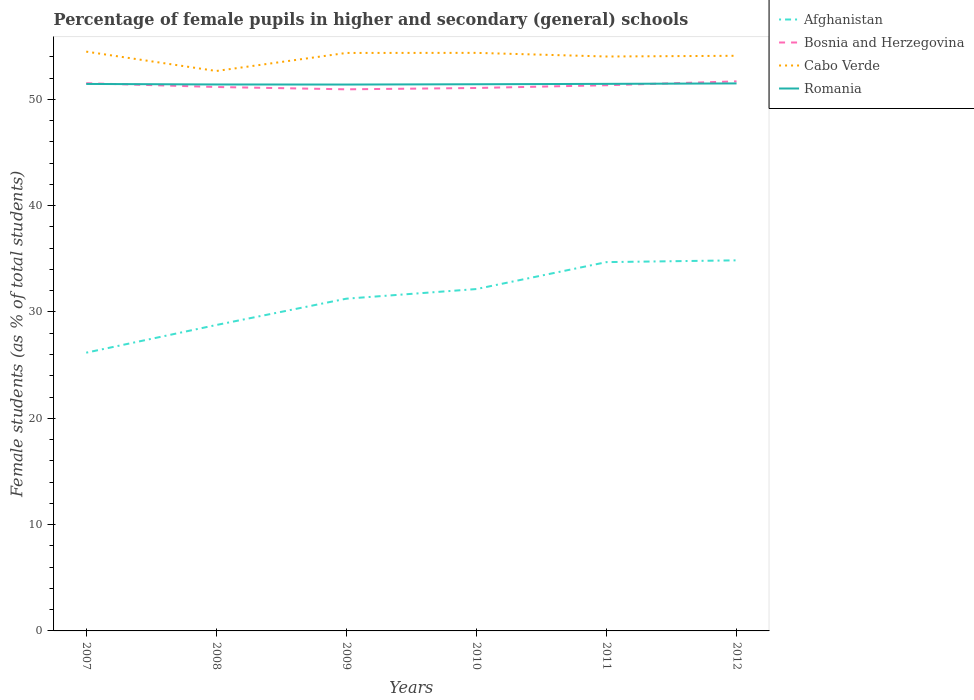Does the line corresponding to Afghanistan intersect with the line corresponding to Cabo Verde?
Provide a short and direct response. No. Is the number of lines equal to the number of legend labels?
Give a very brief answer. Yes. Across all years, what is the maximum percentage of female pupils in higher and secondary schools in Cabo Verde?
Give a very brief answer. 52.66. What is the total percentage of female pupils in higher and secondary schools in Cabo Verde in the graph?
Ensure brevity in your answer.  1.82. What is the difference between the highest and the second highest percentage of female pupils in higher and secondary schools in Cabo Verde?
Your answer should be compact. 1.82. Is the percentage of female pupils in higher and secondary schools in Cabo Verde strictly greater than the percentage of female pupils in higher and secondary schools in Romania over the years?
Provide a short and direct response. No. How many lines are there?
Provide a succinct answer. 4. Are the values on the major ticks of Y-axis written in scientific E-notation?
Make the answer very short. No. Does the graph contain grids?
Your response must be concise. No. Where does the legend appear in the graph?
Offer a very short reply. Top right. How many legend labels are there?
Provide a succinct answer. 4. What is the title of the graph?
Provide a short and direct response. Percentage of female pupils in higher and secondary (general) schools. What is the label or title of the Y-axis?
Give a very brief answer. Female students (as % of total students). What is the Female students (as % of total students) of Afghanistan in 2007?
Offer a terse response. 26.17. What is the Female students (as % of total students) in Bosnia and Herzegovina in 2007?
Ensure brevity in your answer.  51.51. What is the Female students (as % of total students) in Cabo Verde in 2007?
Offer a very short reply. 54.48. What is the Female students (as % of total students) of Romania in 2007?
Give a very brief answer. 51.45. What is the Female students (as % of total students) of Afghanistan in 2008?
Your answer should be compact. 28.77. What is the Female students (as % of total students) of Bosnia and Herzegovina in 2008?
Ensure brevity in your answer.  51.16. What is the Female students (as % of total students) in Cabo Verde in 2008?
Give a very brief answer. 52.66. What is the Female students (as % of total students) in Romania in 2008?
Offer a very short reply. 51.4. What is the Female students (as % of total students) in Afghanistan in 2009?
Your answer should be very brief. 31.25. What is the Female students (as % of total students) in Bosnia and Herzegovina in 2009?
Provide a succinct answer. 50.94. What is the Female students (as % of total students) of Cabo Verde in 2009?
Give a very brief answer. 54.36. What is the Female students (as % of total students) of Romania in 2009?
Make the answer very short. 51.39. What is the Female students (as % of total students) in Afghanistan in 2010?
Provide a succinct answer. 32.15. What is the Female students (as % of total students) of Bosnia and Herzegovina in 2010?
Offer a very short reply. 51.06. What is the Female students (as % of total students) in Cabo Verde in 2010?
Offer a very short reply. 54.37. What is the Female students (as % of total students) in Romania in 2010?
Your answer should be very brief. 51.42. What is the Female students (as % of total students) of Afghanistan in 2011?
Offer a very short reply. 34.69. What is the Female students (as % of total students) of Bosnia and Herzegovina in 2011?
Offer a very short reply. 51.32. What is the Female students (as % of total students) in Cabo Verde in 2011?
Offer a very short reply. 54.03. What is the Female students (as % of total students) of Romania in 2011?
Keep it short and to the point. 51.45. What is the Female students (as % of total students) of Afghanistan in 2012?
Provide a short and direct response. 34.85. What is the Female students (as % of total students) in Bosnia and Herzegovina in 2012?
Offer a terse response. 51.69. What is the Female students (as % of total students) in Cabo Verde in 2012?
Make the answer very short. 54.09. What is the Female students (as % of total students) in Romania in 2012?
Your answer should be compact. 51.49. Across all years, what is the maximum Female students (as % of total students) in Afghanistan?
Provide a succinct answer. 34.85. Across all years, what is the maximum Female students (as % of total students) in Bosnia and Herzegovina?
Give a very brief answer. 51.69. Across all years, what is the maximum Female students (as % of total students) of Cabo Verde?
Offer a very short reply. 54.48. Across all years, what is the maximum Female students (as % of total students) of Romania?
Your answer should be very brief. 51.49. Across all years, what is the minimum Female students (as % of total students) of Afghanistan?
Your answer should be very brief. 26.17. Across all years, what is the minimum Female students (as % of total students) of Bosnia and Herzegovina?
Keep it short and to the point. 50.94. Across all years, what is the minimum Female students (as % of total students) of Cabo Verde?
Your answer should be compact. 52.66. Across all years, what is the minimum Female students (as % of total students) in Romania?
Provide a succinct answer. 51.39. What is the total Female students (as % of total students) in Afghanistan in the graph?
Ensure brevity in your answer.  187.88. What is the total Female students (as % of total students) in Bosnia and Herzegovina in the graph?
Provide a succinct answer. 307.69. What is the total Female students (as % of total students) in Cabo Verde in the graph?
Keep it short and to the point. 324. What is the total Female students (as % of total students) of Romania in the graph?
Offer a terse response. 308.59. What is the difference between the Female students (as % of total students) in Afghanistan in 2007 and that in 2008?
Your answer should be very brief. -2.6. What is the difference between the Female students (as % of total students) in Bosnia and Herzegovina in 2007 and that in 2008?
Keep it short and to the point. 0.36. What is the difference between the Female students (as % of total students) in Cabo Verde in 2007 and that in 2008?
Give a very brief answer. 1.82. What is the difference between the Female students (as % of total students) in Romania in 2007 and that in 2008?
Give a very brief answer. 0.05. What is the difference between the Female students (as % of total students) in Afghanistan in 2007 and that in 2009?
Provide a succinct answer. -5.08. What is the difference between the Female students (as % of total students) of Bosnia and Herzegovina in 2007 and that in 2009?
Offer a terse response. 0.57. What is the difference between the Female students (as % of total students) in Cabo Verde in 2007 and that in 2009?
Your response must be concise. 0.12. What is the difference between the Female students (as % of total students) in Romania in 2007 and that in 2009?
Make the answer very short. 0.06. What is the difference between the Female students (as % of total students) in Afghanistan in 2007 and that in 2010?
Your response must be concise. -5.99. What is the difference between the Female students (as % of total students) in Bosnia and Herzegovina in 2007 and that in 2010?
Make the answer very short. 0.45. What is the difference between the Female students (as % of total students) of Cabo Verde in 2007 and that in 2010?
Make the answer very short. 0.12. What is the difference between the Female students (as % of total students) of Romania in 2007 and that in 2010?
Your answer should be very brief. 0.03. What is the difference between the Female students (as % of total students) in Afghanistan in 2007 and that in 2011?
Offer a terse response. -8.52. What is the difference between the Female students (as % of total students) of Bosnia and Herzegovina in 2007 and that in 2011?
Provide a short and direct response. 0.19. What is the difference between the Female students (as % of total students) in Cabo Verde in 2007 and that in 2011?
Offer a terse response. 0.46. What is the difference between the Female students (as % of total students) in Romania in 2007 and that in 2011?
Ensure brevity in your answer.  -0.01. What is the difference between the Female students (as % of total students) of Afghanistan in 2007 and that in 2012?
Ensure brevity in your answer.  -8.68. What is the difference between the Female students (as % of total students) of Bosnia and Herzegovina in 2007 and that in 2012?
Your response must be concise. -0.17. What is the difference between the Female students (as % of total students) of Cabo Verde in 2007 and that in 2012?
Keep it short and to the point. 0.39. What is the difference between the Female students (as % of total students) of Romania in 2007 and that in 2012?
Make the answer very short. -0.05. What is the difference between the Female students (as % of total students) of Afghanistan in 2008 and that in 2009?
Offer a very short reply. -2.48. What is the difference between the Female students (as % of total students) in Bosnia and Herzegovina in 2008 and that in 2009?
Make the answer very short. 0.22. What is the difference between the Female students (as % of total students) in Cabo Verde in 2008 and that in 2009?
Provide a succinct answer. -1.7. What is the difference between the Female students (as % of total students) of Romania in 2008 and that in 2009?
Your answer should be very brief. 0.01. What is the difference between the Female students (as % of total students) of Afghanistan in 2008 and that in 2010?
Your answer should be very brief. -3.38. What is the difference between the Female students (as % of total students) of Bosnia and Herzegovina in 2008 and that in 2010?
Offer a terse response. 0.09. What is the difference between the Female students (as % of total students) of Cabo Verde in 2008 and that in 2010?
Provide a succinct answer. -1.7. What is the difference between the Female students (as % of total students) of Romania in 2008 and that in 2010?
Offer a terse response. -0.02. What is the difference between the Female students (as % of total students) of Afghanistan in 2008 and that in 2011?
Make the answer very short. -5.92. What is the difference between the Female students (as % of total students) in Bosnia and Herzegovina in 2008 and that in 2011?
Ensure brevity in your answer.  -0.17. What is the difference between the Female students (as % of total students) of Cabo Verde in 2008 and that in 2011?
Your response must be concise. -1.36. What is the difference between the Female students (as % of total students) of Romania in 2008 and that in 2011?
Offer a terse response. -0.06. What is the difference between the Female students (as % of total students) in Afghanistan in 2008 and that in 2012?
Make the answer very short. -6.08. What is the difference between the Female students (as % of total students) in Bosnia and Herzegovina in 2008 and that in 2012?
Your answer should be compact. -0.53. What is the difference between the Female students (as % of total students) of Cabo Verde in 2008 and that in 2012?
Give a very brief answer. -1.43. What is the difference between the Female students (as % of total students) of Romania in 2008 and that in 2012?
Make the answer very short. -0.1. What is the difference between the Female students (as % of total students) of Afghanistan in 2009 and that in 2010?
Offer a terse response. -0.91. What is the difference between the Female students (as % of total students) in Bosnia and Herzegovina in 2009 and that in 2010?
Provide a succinct answer. -0.12. What is the difference between the Female students (as % of total students) of Cabo Verde in 2009 and that in 2010?
Your answer should be very brief. -0.01. What is the difference between the Female students (as % of total students) in Romania in 2009 and that in 2010?
Provide a succinct answer. -0.03. What is the difference between the Female students (as % of total students) of Afghanistan in 2009 and that in 2011?
Your answer should be compact. -3.44. What is the difference between the Female students (as % of total students) of Bosnia and Herzegovina in 2009 and that in 2011?
Offer a terse response. -0.38. What is the difference between the Female students (as % of total students) in Cabo Verde in 2009 and that in 2011?
Give a very brief answer. 0.34. What is the difference between the Female students (as % of total students) in Romania in 2009 and that in 2011?
Offer a very short reply. -0.06. What is the difference between the Female students (as % of total students) of Afghanistan in 2009 and that in 2012?
Your answer should be compact. -3.61. What is the difference between the Female students (as % of total students) in Bosnia and Herzegovina in 2009 and that in 2012?
Your answer should be very brief. -0.75. What is the difference between the Female students (as % of total students) in Cabo Verde in 2009 and that in 2012?
Keep it short and to the point. 0.27. What is the difference between the Female students (as % of total students) of Romania in 2009 and that in 2012?
Ensure brevity in your answer.  -0.11. What is the difference between the Female students (as % of total students) in Afghanistan in 2010 and that in 2011?
Offer a very short reply. -2.53. What is the difference between the Female students (as % of total students) of Bosnia and Herzegovina in 2010 and that in 2011?
Keep it short and to the point. -0.26. What is the difference between the Female students (as % of total students) of Cabo Verde in 2010 and that in 2011?
Offer a very short reply. 0.34. What is the difference between the Female students (as % of total students) in Romania in 2010 and that in 2011?
Ensure brevity in your answer.  -0.04. What is the difference between the Female students (as % of total students) in Afghanistan in 2010 and that in 2012?
Offer a terse response. -2.7. What is the difference between the Female students (as % of total students) in Bosnia and Herzegovina in 2010 and that in 2012?
Provide a succinct answer. -0.62. What is the difference between the Female students (as % of total students) in Cabo Verde in 2010 and that in 2012?
Provide a short and direct response. 0.27. What is the difference between the Female students (as % of total students) in Romania in 2010 and that in 2012?
Ensure brevity in your answer.  -0.08. What is the difference between the Female students (as % of total students) in Afghanistan in 2011 and that in 2012?
Offer a terse response. -0.17. What is the difference between the Female students (as % of total students) in Bosnia and Herzegovina in 2011 and that in 2012?
Provide a succinct answer. -0.36. What is the difference between the Female students (as % of total students) of Cabo Verde in 2011 and that in 2012?
Keep it short and to the point. -0.07. What is the difference between the Female students (as % of total students) of Romania in 2011 and that in 2012?
Provide a short and direct response. -0.04. What is the difference between the Female students (as % of total students) of Afghanistan in 2007 and the Female students (as % of total students) of Bosnia and Herzegovina in 2008?
Provide a succinct answer. -24.99. What is the difference between the Female students (as % of total students) in Afghanistan in 2007 and the Female students (as % of total students) in Cabo Verde in 2008?
Your answer should be compact. -26.49. What is the difference between the Female students (as % of total students) of Afghanistan in 2007 and the Female students (as % of total students) of Romania in 2008?
Keep it short and to the point. -25.23. What is the difference between the Female students (as % of total students) in Bosnia and Herzegovina in 2007 and the Female students (as % of total students) in Cabo Verde in 2008?
Your answer should be compact. -1.15. What is the difference between the Female students (as % of total students) of Bosnia and Herzegovina in 2007 and the Female students (as % of total students) of Romania in 2008?
Your answer should be compact. 0.12. What is the difference between the Female students (as % of total students) in Cabo Verde in 2007 and the Female students (as % of total students) in Romania in 2008?
Make the answer very short. 3.09. What is the difference between the Female students (as % of total students) in Afghanistan in 2007 and the Female students (as % of total students) in Bosnia and Herzegovina in 2009?
Your response must be concise. -24.77. What is the difference between the Female students (as % of total students) in Afghanistan in 2007 and the Female students (as % of total students) in Cabo Verde in 2009?
Make the answer very short. -28.19. What is the difference between the Female students (as % of total students) in Afghanistan in 2007 and the Female students (as % of total students) in Romania in 2009?
Provide a succinct answer. -25.22. What is the difference between the Female students (as % of total students) in Bosnia and Herzegovina in 2007 and the Female students (as % of total students) in Cabo Verde in 2009?
Your answer should be compact. -2.85. What is the difference between the Female students (as % of total students) of Bosnia and Herzegovina in 2007 and the Female students (as % of total students) of Romania in 2009?
Provide a succinct answer. 0.12. What is the difference between the Female students (as % of total students) of Cabo Verde in 2007 and the Female students (as % of total students) of Romania in 2009?
Your answer should be compact. 3.1. What is the difference between the Female students (as % of total students) of Afghanistan in 2007 and the Female students (as % of total students) of Bosnia and Herzegovina in 2010?
Provide a succinct answer. -24.9. What is the difference between the Female students (as % of total students) in Afghanistan in 2007 and the Female students (as % of total students) in Cabo Verde in 2010?
Offer a very short reply. -28.2. What is the difference between the Female students (as % of total students) in Afghanistan in 2007 and the Female students (as % of total students) in Romania in 2010?
Your response must be concise. -25.25. What is the difference between the Female students (as % of total students) of Bosnia and Herzegovina in 2007 and the Female students (as % of total students) of Cabo Verde in 2010?
Give a very brief answer. -2.85. What is the difference between the Female students (as % of total students) in Bosnia and Herzegovina in 2007 and the Female students (as % of total students) in Romania in 2010?
Offer a very short reply. 0.1. What is the difference between the Female students (as % of total students) in Cabo Verde in 2007 and the Female students (as % of total students) in Romania in 2010?
Make the answer very short. 3.07. What is the difference between the Female students (as % of total students) of Afghanistan in 2007 and the Female students (as % of total students) of Bosnia and Herzegovina in 2011?
Provide a succinct answer. -25.15. What is the difference between the Female students (as % of total students) in Afghanistan in 2007 and the Female students (as % of total students) in Cabo Verde in 2011?
Your answer should be compact. -27.86. What is the difference between the Female students (as % of total students) in Afghanistan in 2007 and the Female students (as % of total students) in Romania in 2011?
Offer a terse response. -25.28. What is the difference between the Female students (as % of total students) in Bosnia and Herzegovina in 2007 and the Female students (as % of total students) in Cabo Verde in 2011?
Offer a very short reply. -2.51. What is the difference between the Female students (as % of total students) of Cabo Verde in 2007 and the Female students (as % of total students) of Romania in 2011?
Your answer should be compact. 3.03. What is the difference between the Female students (as % of total students) of Afghanistan in 2007 and the Female students (as % of total students) of Bosnia and Herzegovina in 2012?
Provide a succinct answer. -25.52. What is the difference between the Female students (as % of total students) of Afghanistan in 2007 and the Female students (as % of total students) of Cabo Verde in 2012?
Ensure brevity in your answer.  -27.92. What is the difference between the Female students (as % of total students) in Afghanistan in 2007 and the Female students (as % of total students) in Romania in 2012?
Give a very brief answer. -25.32. What is the difference between the Female students (as % of total students) of Bosnia and Herzegovina in 2007 and the Female students (as % of total students) of Cabo Verde in 2012?
Your answer should be very brief. -2.58. What is the difference between the Female students (as % of total students) in Bosnia and Herzegovina in 2007 and the Female students (as % of total students) in Romania in 2012?
Provide a succinct answer. 0.02. What is the difference between the Female students (as % of total students) of Cabo Verde in 2007 and the Female students (as % of total students) of Romania in 2012?
Give a very brief answer. 2.99. What is the difference between the Female students (as % of total students) of Afghanistan in 2008 and the Female students (as % of total students) of Bosnia and Herzegovina in 2009?
Offer a terse response. -22.17. What is the difference between the Female students (as % of total students) of Afghanistan in 2008 and the Female students (as % of total students) of Cabo Verde in 2009?
Provide a succinct answer. -25.59. What is the difference between the Female students (as % of total students) in Afghanistan in 2008 and the Female students (as % of total students) in Romania in 2009?
Make the answer very short. -22.62. What is the difference between the Female students (as % of total students) of Bosnia and Herzegovina in 2008 and the Female students (as % of total students) of Cabo Verde in 2009?
Provide a short and direct response. -3.2. What is the difference between the Female students (as % of total students) of Bosnia and Herzegovina in 2008 and the Female students (as % of total students) of Romania in 2009?
Ensure brevity in your answer.  -0.23. What is the difference between the Female students (as % of total students) of Cabo Verde in 2008 and the Female students (as % of total students) of Romania in 2009?
Your response must be concise. 1.28. What is the difference between the Female students (as % of total students) in Afghanistan in 2008 and the Female students (as % of total students) in Bosnia and Herzegovina in 2010?
Offer a terse response. -22.29. What is the difference between the Female students (as % of total students) in Afghanistan in 2008 and the Female students (as % of total students) in Cabo Verde in 2010?
Make the answer very short. -25.6. What is the difference between the Female students (as % of total students) of Afghanistan in 2008 and the Female students (as % of total students) of Romania in 2010?
Your answer should be compact. -22.64. What is the difference between the Female students (as % of total students) in Bosnia and Herzegovina in 2008 and the Female students (as % of total students) in Cabo Verde in 2010?
Your response must be concise. -3.21. What is the difference between the Female students (as % of total students) in Bosnia and Herzegovina in 2008 and the Female students (as % of total students) in Romania in 2010?
Provide a succinct answer. -0.26. What is the difference between the Female students (as % of total students) in Cabo Verde in 2008 and the Female students (as % of total students) in Romania in 2010?
Your answer should be compact. 1.25. What is the difference between the Female students (as % of total students) of Afghanistan in 2008 and the Female students (as % of total students) of Bosnia and Herzegovina in 2011?
Give a very brief answer. -22.55. What is the difference between the Female students (as % of total students) in Afghanistan in 2008 and the Female students (as % of total students) in Cabo Verde in 2011?
Your response must be concise. -25.25. What is the difference between the Female students (as % of total students) in Afghanistan in 2008 and the Female students (as % of total students) in Romania in 2011?
Provide a succinct answer. -22.68. What is the difference between the Female students (as % of total students) in Bosnia and Herzegovina in 2008 and the Female students (as % of total students) in Cabo Verde in 2011?
Offer a very short reply. -2.87. What is the difference between the Female students (as % of total students) of Bosnia and Herzegovina in 2008 and the Female students (as % of total students) of Romania in 2011?
Give a very brief answer. -0.3. What is the difference between the Female students (as % of total students) of Cabo Verde in 2008 and the Female students (as % of total students) of Romania in 2011?
Provide a succinct answer. 1.21. What is the difference between the Female students (as % of total students) of Afghanistan in 2008 and the Female students (as % of total students) of Bosnia and Herzegovina in 2012?
Provide a short and direct response. -22.92. What is the difference between the Female students (as % of total students) of Afghanistan in 2008 and the Female students (as % of total students) of Cabo Verde in 2012?
Make the answer very short. -25.32. What is the difference between the Female students (as % of total students) in Afghanistan in 2008 and the Female students (as % of total students) in Romania in 2012?
Ensure brevity in your answer.  -22.72. What is the difference between the Female students (as % of total students) in Bosnia and Herzegovina in 2008 and the Female students (as % of total students) in Cabo Verde in 2012?
Offer a very short reply. -2.94. What is the difference between the Female students (as % of total students) of Bosnia and Herzegovina in 2008 and the Female students (as % of total students) of Romania in 2012?
Offer a terse response. -0.34. What is the difference between the Female students (as % of total students) of Cabo Verde in 2008 and the Female students (as % of total students) of Romania in 2012?
Provide a short and direct response. 1.17. What is the difference between the Female students (as % of total students) of Afghanistan in 2009 and the Female students (as % of total students) of Bosnia and Herzegovina in 2010?
Provide a short and direct response. -19.82. What is the difference between the Female students (as % of total students) in Afghanistan in 2009 and the Female students (as % of total students) in Cabo Verde in 2010?
Offer a terse response. -23.12. What is the difference between the Female students (as % of total students) in Afghanistan in 2009 and the Female students (as % of total students) in Romania in 2010?
Your response must be concise. -20.17. What is the difference between the Female students (as % of total students) of Bosnia and Herzegovina in 2009 and the Female students (as % of total students) of Cabo Verde in 2010?
Your answer should be very brief. -3.43. What is the difference between the Female students (as % of total students) of Bosnia and Herzegovina in 2009 and the Female students (as % of total students) of Romania in 2010?
Offer a very short reply. -0.48. What is the difference between the Female students (as % of total students) of Cabo Verde in 2009 and the Female students (as % of total students) of Romania in 2010?
Offer a very short reply. 2.94. What is the difference between the Female students (as % of total students) of Afghanistan in 2009 and the Female students (as % of total students) of Bosnia and Herzegovina in 2011?
Your response must be concise. -20.08. What is the difference between the Female students (as % of total students) of Afghanistan in 2009 and the Female students (as % of total students) of Cabo Verde in 2011?
Your answer should be very brief. -22.78. What is the difference between the Female students (as % of total students) in Afghanistan in 2009 and the Female students (as % of total students) in Romania in 2011?
Keep it short and to the point. -20.2. What is the difference between the Female students (as % of total students) of Bosnia and Herzegovina in 2009 and the Female students (as % of total students) of Cabo Verde in 2011?
Offer a terse response. -3.09. What is the difference between the Female students (as % of total students) in Bosnia and Herzegovina in 2009 and the Female students (as % of total students) in Romania in 2011?
Keep it short and to the point. -0.51. What is the difference between the Female students (as % of total students) of Cabo Verde in 2009 and the Female students (as % of total students) of Romania in 2011?
Offer a very short reply. 2.91. What is the difference between the Female students (as % of total students) in Afghanistan in 2009 and the Female students (as % of total students) in Bosnia and Herzegovina in 2012?
Offer a terse response. -20.44. What is the difference between the Female students (as % of total students) in Afghanistan in 2009 and the Female students (as % of total students) in Cabo Verde in 2012?
Offer a terse response. -22.84. What is the difference between the Female students (as % of total students) of Afghanistan in 2009 and the Female students (as % of total students) of Romania in 2012?
Give a very brief answer. -20.25. What is the difference between the Female students (as % of total students) in Bosnia and Herzegovina in 2009 and the Female students (as % of total students) in Cabo Verde in 2012?
Offer a very short reply. -3.15. What is the difference between the Female students (as % of total students) in Bosnia and Herzegovina in 2009 and the Female students (as % of total students) in Romania in 2012?
Ensure brevity in your answer.  -0.55. What is the difference between the Female students (as % of total students) in Cabo Verde in 2009 and the Female students (as % of total students) in Romania in 2012?
Offer a very short reply. 2.87. What is the difference between the Female students (as % of total students) in Afghanistan in 2010 and the Female students (as % of total students) in Bosnia and Herzegovina in 2011?
Provide a succinct answer. -19.17. What is the difference between the Female students (as % of total students) in Afghanistan in 2010 and the Female students (as % of total students) in Cabo Verde in 2011?
Provide a short and direct response. -21.87. What is the difference between the Female students (as % of total students) of Afghanistan in 2010 and the Female students (as % of total students) of Romania in 2011?
Your answer should be very brief. -19.3. What is the difference between the Female students (as % of total students) in Bosnia and Herzegovina in 2010 and the Female students (as % of total students) in Cabo Verde in 2011?
Give a very brief answer. -2.96. What is the difference between the Female students (as % of total students) in Bosnia and Herzegovina in 2010 and the Female students (as % of total students) in Romania in 2011?
Ensure brevity in your answer.  -0.39. What is the difference between the Female students (as % of total students) in Cabo Verde in 2010 and the Female students (as % of total students) in Romania in 2011?
Ensure brevity in your answer.  2.91. What is the difference between the Female students (as % of total students) in Afghanistan in 2010 and the Female students (as % of total students) in Bosnia and Herzegovina in 2012?
Give a very brief answer. -19.53. What is the difference between the Female students (as % of total students) of Afghanistan in 2010 and the Female students (as % of total students) of Cabo Verde in 2012?
Your response must be concise. -21.94. What is the difference between the Female students (as % of total students) in Afghanistan in 2010 and the Female students (as % of total students) in Romania in 2012?
Give a very brief answer. -19.34. What is the difference between the Female students (as % of total students) of Bosnia and Herzegovina in 2010 and the Female students (as % of total students) of Cabo Verde in 2012?
Ensure brevity in your answer.  -3.03. What is the difference between the Female students (as % of total students) of Bosnia and Herzegovina in 2010 and the Female students (as % of total students) of Romania in 2012?
Offer a very short reply. -0.43. What is the difference between the Female students (as % of total students) in Cabo Verde in 2010 and the Female students (as % of total students) in Romania in 2012?
Provide a succinct answer. 2.87. What is the difference between the Female students (as % of total students) in Afghanistan in 2011 and the Female students (as % of total students) in Bosnia and Herzegovina in 2012?
Provide a succinct answer. -17. What is the difference between the Female students (as % of total students) of Afghanistan in 2011 and the Female students (as % of total students) of Cabo Verde in 2012?
Provide a succinct answer. -19.41. What is the difference between the Female students (as % of total students) of Afghanistan in 2011 and the Female students (as % of total students) of Romania in 2012?
Provide a succinct answer. -16.81. What is the difference between the Female students (as % of total students) in Bosnia and Herzegovina in 2011 and the Female students (as % of total students) in Cabo Verde in 2012?
Your response must be concise. -2.77. What is the difference between the Female students (as % of total students) in Bosnia and Herzegovina in 2011 and the Female students (as % of total students) in Romania in 2012?
Keep it short and to the point. -0.17. What is the difference between the Female students (as % of total students) of Cabo Verde in 2011 and the Female students (as % of total students) of Romania in 2012?
Your answer should be very brief. 2.53. What is the average Female students (as % of total students) in Afghanistan per year?
Your response must be concise. 31.31. What is the average Female students (as % of total students) of Bosnia and Herzegovina per year?
Ensure brevity in your answer.  51.28. What is the average Female students (as % of total students) in Cabo Verde per year?
Give a very brief answer. 54. What is the average Female students (as % of total students) in Romania per year?
Make the answer very short. 51.43. In the year 2007, what is the difference between the Female students (as % of total students) of Afghanistan and Female students (as % of total students) of Bosnia and Herzegovina?
Offer a very short reply. -25.34. In the year 2007, what is the difference between the Female students (as % of total students) of Afghanistan and Female students (as % of total students) of Cabo Verde?
Offer a terse response. -28.32. In the year 2007, what is the difference between the Female students (as % of total students) in Afghanistan and Female students (as % of total students) in Romania?
Make the answer very short. -25.28. In the year 2007, what is the difference between the Female students (as % of total students) in Bosnia and Herzegovina and Female students (as % of total students) in Cabo Verde?
Offer a very short reply. -2.97. In the year 2007, what is the difference between the Female students (as % of total students) in Bosnia and Herzegovina and Female students (as % of total students) in Romania?
Keep it short and to the point. 0.07. In the year 2007, what is the difference between the Female students (as % of total students) in Cabo Verde and Female students (as % of total students) in Romania?
Provide a succinct answer. 3.04. In the year 2008, what is the difference between the Female students (as % of total students) in Afghanistan and Female students (as % of total students) in Bosnia and Herzegovina?
Offer a very short reply. -22.39. In the year 2008, what is the difference between the Female students (as % of total students) in Afghanistan and Female students (as % of total students) in Cabo Verde?
Your response must be concise. -23.89. In the year 2008, what is the difference between the Female students (as % of total students) in Afghanistan and Female students (as % of total students) in Romania?
Provide a succinct answer. -22.62. In the year 2008, what is the difference between the Female students (as % of total students) in Bosnia and Herzegovina and Female students (as % of total students) in Cabo Verde?
Keep it short and to the point. -1.51. In the year 2008, what is the difference between the Female students (as % of total students) in Bosnia and Herzegovina and Female students (as % of total students) in Romania?
Your response must be concise. -0.24. In the year 2008, what is the difference between the Female students (as % of total students) in Cabo Verde and Female students (as % of total students) in Romania?
Your answer should be compact. 1.27. In the year 2009, what is the difference between the Female students (as % of total students) of Afghanistan and Female students (as % of total students) of Bosnia and Herzegovina?
Give a very brief answer. -19.69. In the year 2009, what is the difference between the Female students (as % of total students) in Afghanistan and Female students (as % of total students) in Cabo Verde?
Your answer should be very brief. -23.11. In the year 2009, what is the difference between the Female students (as % of total students) of Afghanistan and Female students (as % of total students) of Romania?
Keep it short and to the point. -20.14. In the year 2009, what is the difference between the Female students (as % of total students) in Bosnia and Herzegovina and Female students (as % of total students) in Cabo Verde?
Provide a succinct answer. -3.42. In the year 2009, what is the difference between the Female students (as % of total students) of Bosnia and Herzegovina and Female students (as % of total students) of Romania?
Offer a very short reply. -0.45. In the year 2009, what is the difference between the Female students (as % of total students) in Cabo Verde and Female students (as % of total students) in Romania?
Offer a very short reply. 2.97. In the year 2010, what is the difference between the Female students (as % of total students) of Afghanistan and Female students (as % of total students) of Bosnia and Herzegovina?
Offer a very short reply. -18.91. In the year 2010, what is the difference between the Female students (as % of total students) of Afghanistan and Female students (as % of total students) of Cabo Verde?
Your answer should be very brief. -22.21. In the year 2010, what is the difference between the Female students (as % of total students) in Afghanistan and Female students (as % of total students) in Romania?
Offer a terse response. -19.26. In the year 2010, what is the difference between the Female students (as % of total students) of Bosnia and Herzegovina and Female students (as % of total students) of Cabo Verde?
Offer a very short reply. -3.3. In the year 2010, what is the difference between the Female students (as % of total students) in Bosnia and Herzegovina and Female students (as % of total students) in Romania?
Offer a terse response. -0.35. In the year 2010, what is the difference between the Female students (as % of total students) of Cabo Verde and Female students (as % of total students) of Romania?
Provide a short and direct response. 2.95. In the year 2011, what is the difference between the Female students (as % of total students) of Afghanistan and Female students (as % of total students) of Bosnia and Herzegovina?
Your answer should be compact. -16.64. In the year 2011, what is the difference between the Female students (as % of total students) in Afghanistan and Female students (as % of total students) in Cabo Verde?
Ensure brevity in your answer.  -19.34. In the year 2011, what is the difference between the Female students (as % of total students) in Afghanistan and Female students (as % of total students) in Romania?
Keep it short and to the point. -16.77. In the year 2011, what is the difference between the Female students (as % of total students) in Bosnia and Herzegovina and Female students (as % of total students) in Cabo Verde?
Your answer should be compact. -2.7. In the year 2011, what is the difference between the Female students (as % of total students) of Bosnia and Herzegovina and Female students (as % of total students) of Romania?
Ensure brevity in your answer.  -0.13. In the year 2011, what is the difference between the Female students (as % of total students) of Cabo Verde and Female students (as % of total students) of Romania?
Your answer should be compact. 2.57. In the year 2012, what is the difference between the Female students (as % of total students) of Afghanistan and Female students (as % of total students) of Bosnia and Herzegovina?
Your answer should be very brief. -16.83. In the year 2012, what is the difference between the Female students (as % of total students) of Afghanistan and Female students (as % of total students) of Cabo Verde?
Your answer should be very brief. -19.24. In the year 2012, what is the difference between the Female students (as % of total students) in Afghanistan and Female students (as % of total students) in Romania?
Provide a short and direct response. -16.64. In the year 2012, what is the difference between the Female students (as % of total students) in Bosnia and Herzegovina and Female students (as % of total students) in Cabo Verde?
Provide a short and direct response. -2.41. In the year 2012, what is the difference between the Female students (as % of total students) in Bosnia and Herzegovina and Female students (as % of total students) in Romania?
Offer a very short reply. 0.19. In the year 2012, what is the difference between the Female students (as % of total students) in Cabo Verde and Female students (as % of total students) in Romania?
Offer a terse response. 2.6. What is the ratio of the Female students (as % of total students) of Afghanistan in 2007 to that in 2008?
Keep it short and to the point. 0.91. What is the ratio of the Female students (as % of total students) in Bosnia and Herzegovina in 2007 to that in 2008?
Your response must be concise. 1.01. What is the ratio of the Female students (as % of total students) of Cabo Verde in 2007 to that in 2008?
Offer a very short reply. 1.03. What is the ratio of the Female students (as % of total students) of Afghanistan in 2007 to that in 2009?
Your answer should be compact. 0.84. What is the ratio of the Female students (as % of total students) of Bosnia and Herzegovina in 2007 to that in 2009?
Your answer should be compact. 1.01. What is the ratio of the Female students (as % of total students) of Romania in 2007 to that in 2009?
Your answer should be very brief. 1. What is the ratio of the Female students (as % of total students) of Afghanistan in 2007 to that in 2010?
Keep it short and to the point. 0.81. What is the ratio of the Female students (as % of total students) in Bosnia and Herzegovina in 2007 to that in 2010?
Provide a short and direct response. 1.01. What is the ratio of the Female students (as % of total students) in Cabo Verde in 2007 to that in 2010?
Provide a succinct answer. 1. What is the ratio of the Female students (as % of total students) in Romania in 2007 to that in 2010?
Make the answer very short. 1. What is the ratio of the Female students (as % of total students) in Afghanistan in 2007 to that in 2011?
Keep it short and to the point. 0.75. What is the ratio of the Female students (as % of total students) of Cabo Verde in 2007 to that in 2011?
Your response must be concise. 1.01. What is the ratio of the Female students (as % of total students) of Romania in 2007 to that in 2011?
Keep it short and to the point. 1. What is the ratio of the Female students (as % of total students) of Afghanistan in 2007 to that in 2012?
Provide a short and direct response. 0.75. What is the ratio of the Female students (as % of total students) in Cabo Verde in 2007 to that in 2012?
Offer a very short reply. 1.01. What is the ratio of the Female students (as % of total students) of Afghanistan in 2008 to that in 2009?
Ensure brevity in your answer.  0.92. What is the ratio of the Female students (as % of total students) in Bosnia and Herzegovina in 2008 to that in 2009?
Your answer should be very brief. 1. What is the ratio of the Female students (as % of total students) of Cabo Verde in 2008 to that in 2009?
Provide a succinct answer. 0.97. What is the ratio of the Female students (as % of total students) in Romania in 2008 to that in 2009?
Your answer should be very brief. 1. What is the ratio of the Female students (as % of total students) of Afghanistan in 2008 to that in 2010?
Give a very brief answer. 0.89. What is the ratio of the Female students (as % of total students) of Cabo Verde in 2008 to that in 2010?
Keep it short and to the point. 0.97. What is the ratio of the Female students (as % of total students) in Romania in 2008 to that in 2010?
Your answer should be very brief. 1. What is the ratio of the Female students (as % of total students) of Afghanistan in 2008 to that in 2011?
Ensure brevity in your answer.  0.83. What is the ratio of the Female students (as % of total students) of Cabo Verde in 2008 to that in 2011?
Your answer should be compact. 0.97. What is the ratio of the Female students (as % of total students) in Romania in 2008 to that in 2011?
Offer a very short reply. 1. What is the ratio of the Female students (as % of total students) of Afghanistan in 2008 to that in 2012?
Ensure brevity in your answer.  0.83. What is the ratio of the Female students (as % of total students) of Bosnia and Herzegovina in 2008 to that in 2012?
Give a very brief answer. 0.99. What is the ratio of the Female students (as % of total students) in Cabo Verde in 2008 to that in 2012?
Ensure brevity in your answer.  0.97. What is the ratio of the Female students (as % of total students) in Romania in 2008 to that in 2012?
Your response must be concise. 1. What is the ratio of the Female students (as % of total students) of Afghanistan in 2009 to that in 2010?
Offer a very short reply. 0.97. What is the ratio of the Female students (as % of total students) of Cabo Verde in 2009 to that in 2010?
Make the answer very short. 1. What is the ratio of the Female students (as % of total students) in Romania in 2009 to that in 2010?
Your response must be concise. 1. What is the ratio of the Female students (as % of total students) of Afghanistan in 2009 to that in 2011?
Keep it short and to the point. 0.9. What is the ratio of the Female students (as % of total students) in Afghanistan in 2009 to that in 2012?
Make the answer very short. 0.9. What is the ratio of the Female students (as % of total students) in Bosnia and Herzegovina in 2009 to that in 2012?
Keep it short and to the point. 0.99. What is the ratio of the Female students (as % of total students) in Cabo Verde in 2009 to that in 2012?
Keep it short and to the point. 1. What is the ratio of the Female students (as % of total students) of Romania in 2009 to that in 2012?
Offer a very short reply. 1. What is the ratio of the Female students (as % of total students) in Afghanistan in 2010 to that in 2011?
Make the answer very short. 0.93. What is the ratio of the Female students (as % of total students) in Afghanistan in 2010 to that in 2012?
Your response must be concise. 0.92. What is the ratio of the Female students (as % of total students) in Bosnia and Herzegovina in 2010 to that in 2012?
Your response must be concise. 0.99. What is the ratio of the Female students (as % of total students) in Romania in 2011 to that in 2012?
Provide a succinct answer. 1. What is the difference between the highest and the second highest Female students (as % of total students) in Afghanistan?
Give a very brief answer. 0.17. What is the difference between the highest and the second highest Female students (as % of total students) of Bosnia and Herzegovina?
Your answer should be very brief. 0.17. What is the difference between the highest and the second highest Female students (as % of total students) of Cabo Verde?
Provide a short and direct response. 0.12. What is the difference between the highest and the second highest Female students (as % of total students) in Romania?
Give a very brief answer. 0.04. What is the difference between the highest and the lowest Female students (as % of total students) in Afghanistan?
Your answer should be very brief. 8.68. What is the difference between the highest and the lowest Female students (as % of total students) of Bosnia and Herzegovina?
Provide a short and direct response. 0.75. What is the difference between the highest and the lowest Female students (as % of total students) in Cabo Verde?
Your answer should be very brief. 1.82. What is the difference between the highest and the lowest Female students (as % of total students) of Romania?
Your answer should be compact. 0.11. 